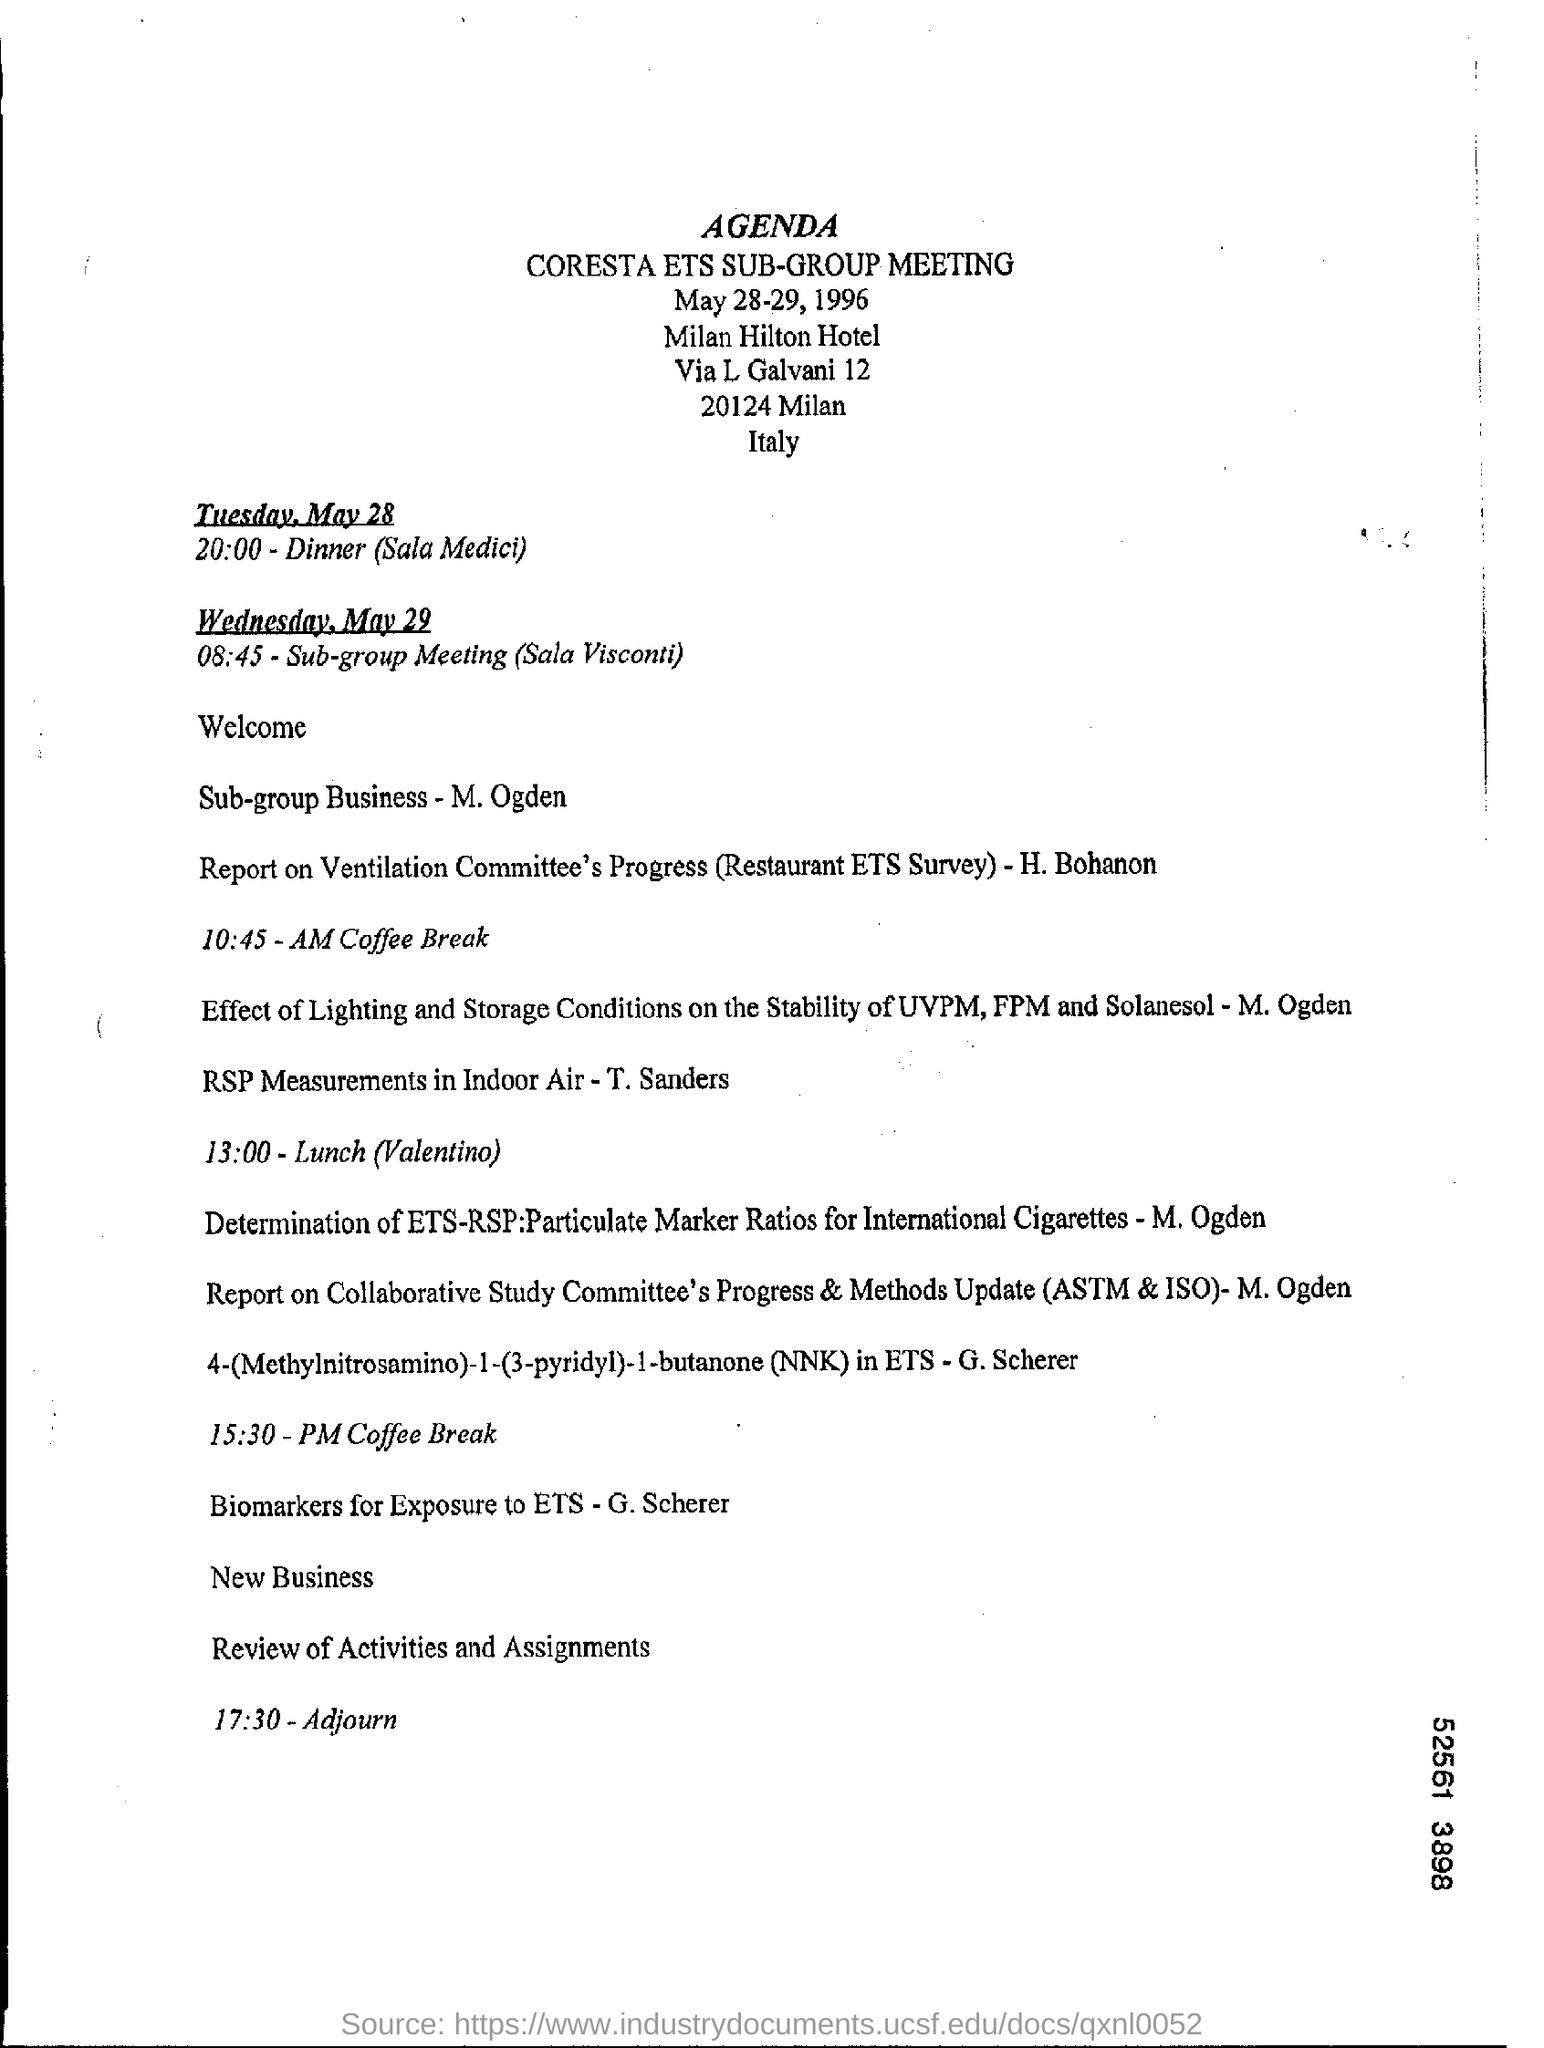Which meeting agenda is given here?
Provide a succinct answer. CORESTA ETS SUB-GROUP MEETING. When does the sub-group meeting starts on Wednesday, May 29?
Give a very brief answer. 08:45. In which Hotel, the CORESTA ETS SUB-GROUP MEETING is planned?
Keep it short and to the point. Milan Hilton Hotel. At what time is the meeting Adjourned?
Your response must be concise. 17:30. 